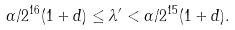<formula> <loc_0><loc_0><loc_500><loc_500>\alpha / 2 ^ { 1 6 } ( 1 + d ) \leq \lambda ^ { \prime } < \alpha / 2 ^ { 1 5 } ( 1 + d ) .</formula> 